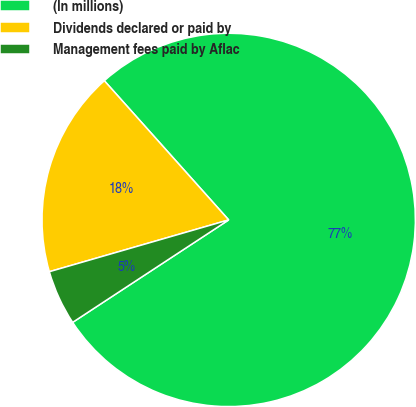Convert chart. <chart><loc_0><loc_0><loc_500><loc_500><pie_chart><fcel>(In millions)<fcel>Dividends declared or paid by<fcel>Management fees paid by Aflac<nl><fcel>77.36%<fcel>17.87%<fcel>4.77%<nl></chart> 